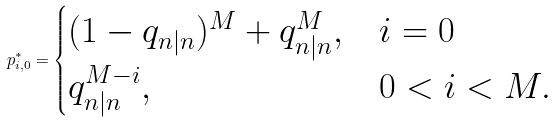Convert formula to latex. <formula><loc_0><loc_0><loc_500><loc_500>p _ { i , 0 } ^ { * } = \begin{cases} ( 1 - q _ { n | n } ) ^ { M } + q _ { n | n } ^ { M } , & i = 0 \\ q _ { n | n } ^ { M - i } , & 0 < i < M . \end{cases}</formula> 